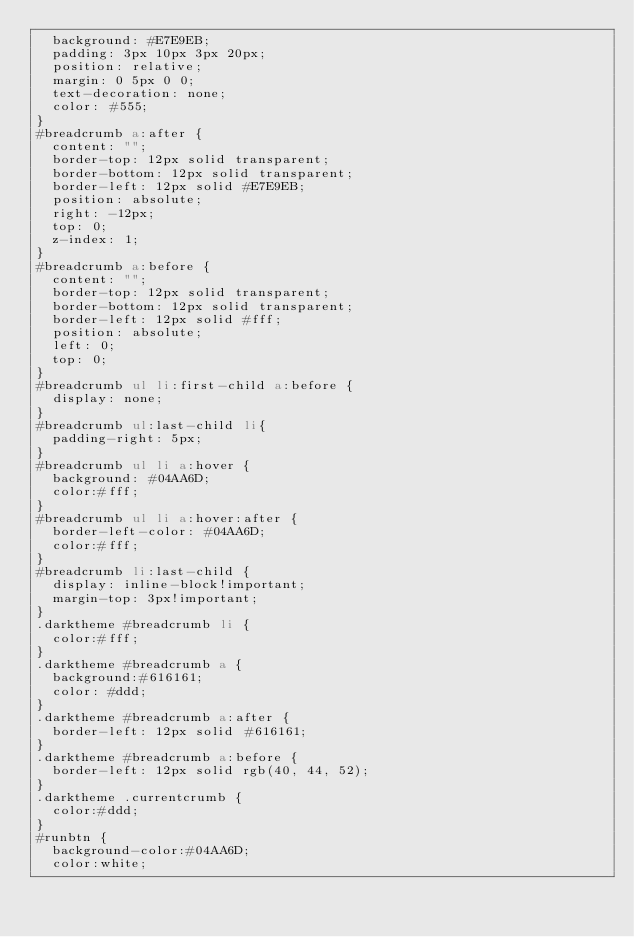Convert code to text. <code><loc_0><loc_0><loc_500><loc_500><_HTML_>  background: #E7E9EB;
  padding: 3px 10px 3px 20px;
  position: relative;
  margin: 0 5px 0 0; 
  text-decoration: none;
  color: #555;
}
#breadcrumb a:after {
  content: "";  
  border-top: 12px solid transparent;
  border-bottom: 12px solid transparent;
  border-left: 12px solid #E7E9EB;
  position: absolute; 
  right: -12px;
  top: 0;
  z-index: 1;
}
#breadcrumb a:before {
  content: "";  
  border-top: 12px solid transparent;
  border-bottom: 12px solid transparent;
  border-left: 12px solid #fff;
  position: absolute; 
  left: 0; 
  top: 0;
}
#breadcrumb ul li:first-child a:before {
  display: none; 
}
#breadcrumb ul:last-child li{
  padding-right: 5px;
}
#breadcrumb ul li a:hover {
  background: #04AA6D;
  color:#fff;
}
#breadcrumb ul li a:hover:after {
  border-left-color: #04AA6D;
  color:#fff;
}
#breadcrumb li:last-child {
  display: inline-block!important;
  margin-top: 3px!important;
}
.darktheme #breadcrumb li {
  color:#fff;
}
.darktheme #breadcrumb a {
  background:#616161;
  color: #ddd;
}	
.darktheme #breadcrumb a:after {
  border-left: 12px solid #616161;
}
.darktheme #breadcrumb a:before {
  border-left: 12px solid rgb(40, 44, 52);
}
.darktheme .currentcrumb {
  color:#ddd;
}
#runbtn {
  background-color:#04AA6D;
  color:white;</code> 